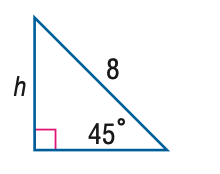Question: Find h.
Choices:
A. 4
B. 4 \sqrt 2
C. 4 \sqrt 3
D. 8
Answer with the letter. Answer: B 